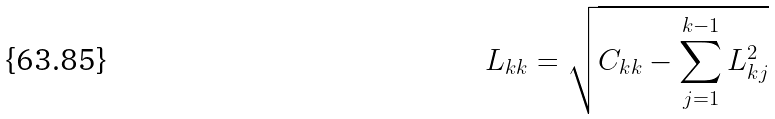<formula> <loc_0><loc_0><loc_500><loc_500>L _ { k k } = \sqrt { C _ { k k } - \sum _ { j = 1 } ^ { k - 1 } L _ { k j } ^ { 2 } }</formula> 